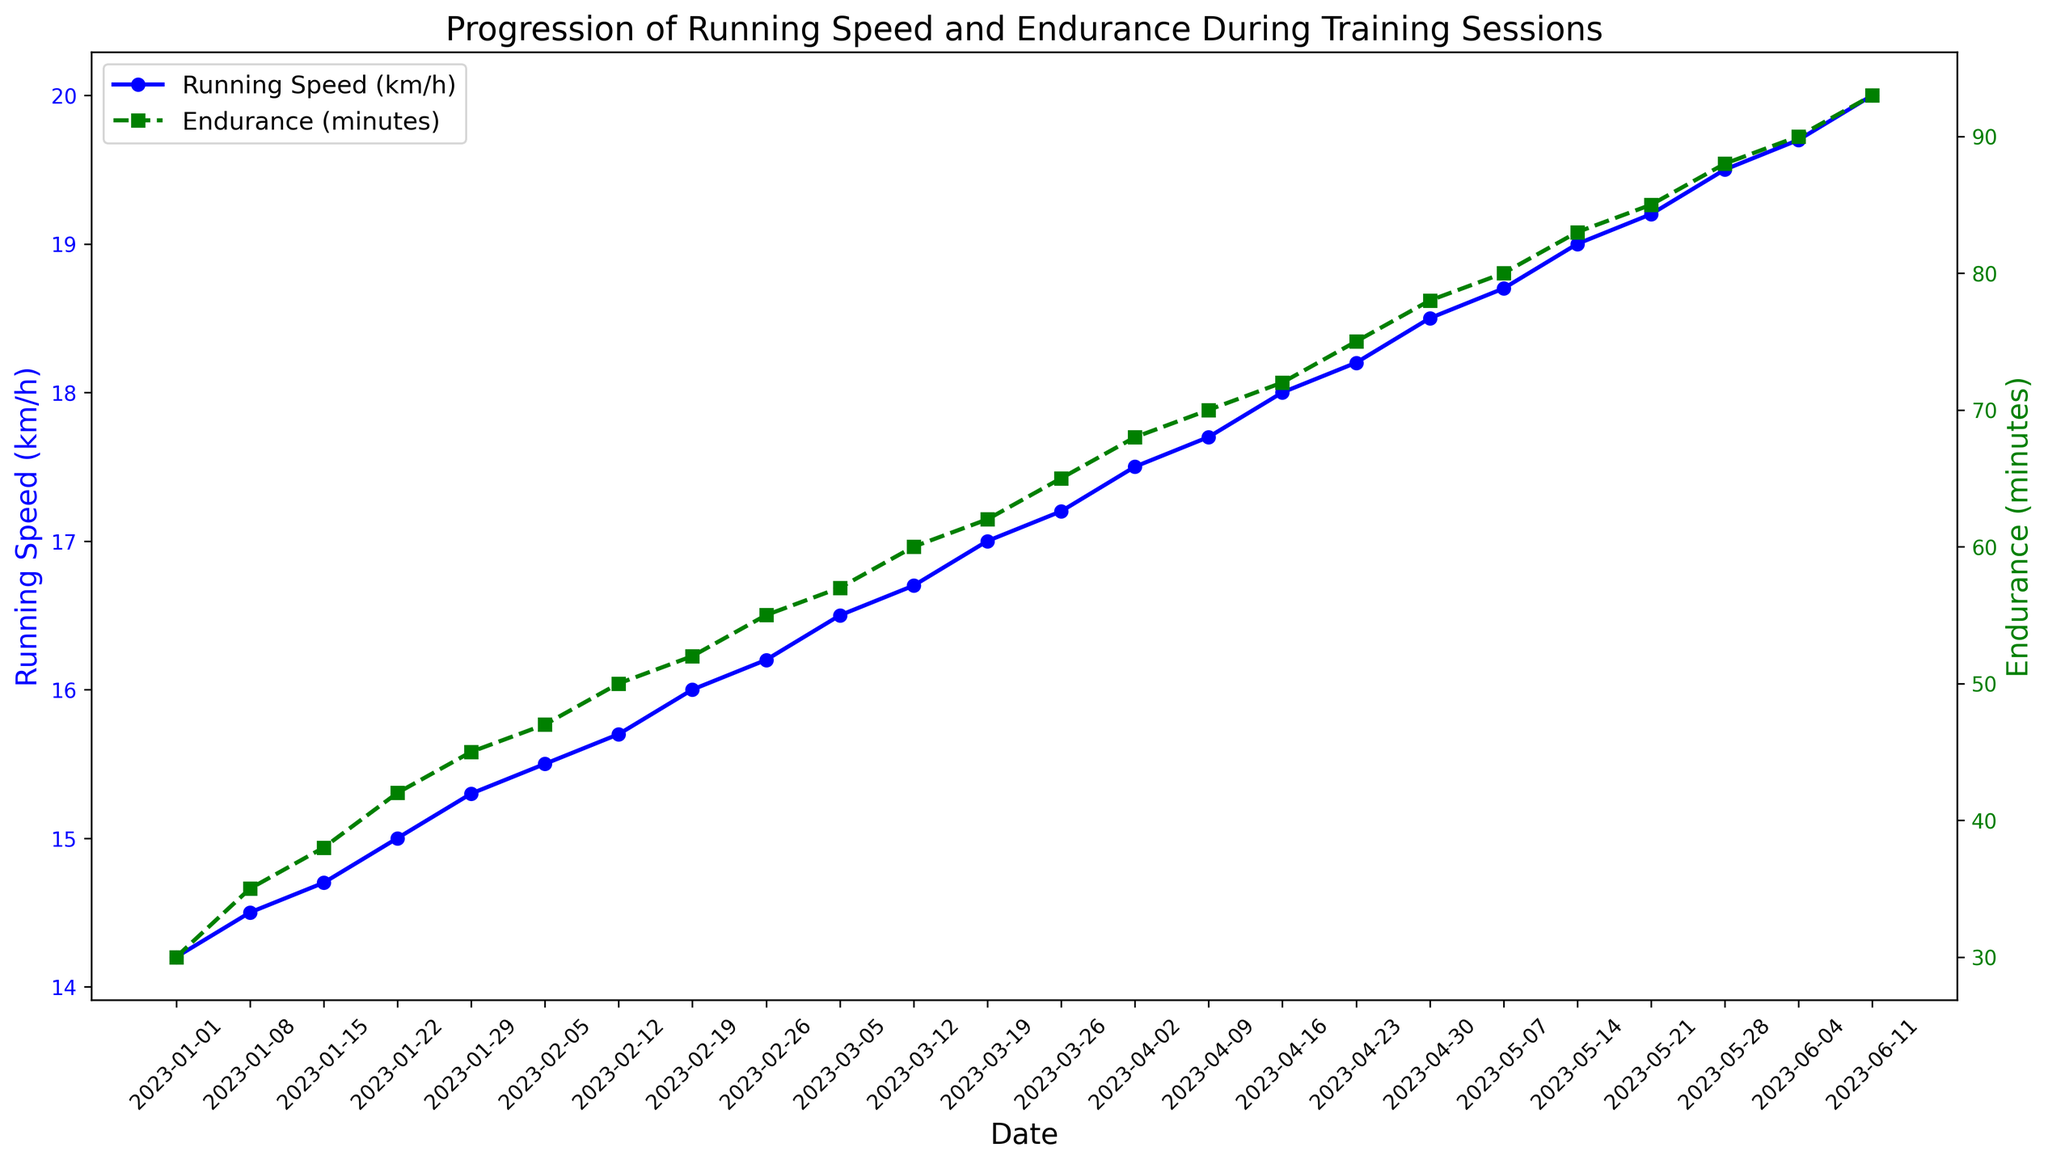Which training session had the highest running speed? The highest running speed can be found by looking at the peak of the blue line on the graph.
Answer: 2023-06-11 What's the total increase in endurance from the first to the last training session? The endurance in the first session was 30 minutes, and in the last session, it was 93 minutes. The total increase is the difference between the two. 93 - 30 = 63 minutes
Answer: 63 minutes How do running speed and endurance change over time during the training sessions? Both the blue and green lines show an upward trend, indicating that both running speed and endurance are increasing over time. Specifically, the blue line for running speed and the green line for endurance both slope upward throughout the sessions.
Answer: They both increase Which had a steeper rate of increase, running speed or endurance? The steepness of the rate of increase can be assessed by comparing the slopes of the blue and green lines. The green line (endurance) shows a sharper incline compared to the blue line (running speed), indicating a steeper rate of increase.
Answer: Endurance Between which two consecutive dates did running speed see the largest increase? To find the largest increase in running speed, examine the segments of the blue line and identify the largest jump. The biggest increase is between 2023-05-28 and 2023-06-04. (From 19.5 to 19.7 km/h)
Answer: 2023-05-28 and 2023-06-04 What is the average running speed over all the training sessions? Sum all running speed values and divide by the number of sessions. (14.2 + 14.5 + 14.7 + 15.0 + 15.3 + 15.5 + 15.7 + 16.0 + 16.2 + 16.5 + 16.7 + 17.0 + 17.2 + 17.5 + 17.7 + 18.0 + 18.2 + 18.5 + 18.7 + 19.0 + 19.2 + 19.5 + 19.7 + 20.0) / 24 = 17.1
Answer: 17.1 km/h During which month did endurance improve the most? Compare the increases in the green line (endurance) month-by-month. April shows the biggest increase: from 65 minutes on 2023-03-26 to 78 minutes on 2023-04-30 (13 minutes).
Answer: April By how much did running speed increase from February to March? Calculate the running speed at the start of February (15.5 km/h on 2023-02-05) and at the end of March (17.2 km/h on 2023-03-26), then find the difference: 17.2 - 15.5 = 1.7 km/h
Answer: 1.7 km/h When did running speed exceed 18 km/h for the first time? The first time the blue line crosses 18 km/h can be located by examining the graph. It exceeds 18 km/h on 2023-04-16.
Answer: 2023-04-16 